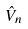<formula> <loc_0><loc_0><loc_500><loc_500>\hat { V } _ { n }</formula> 